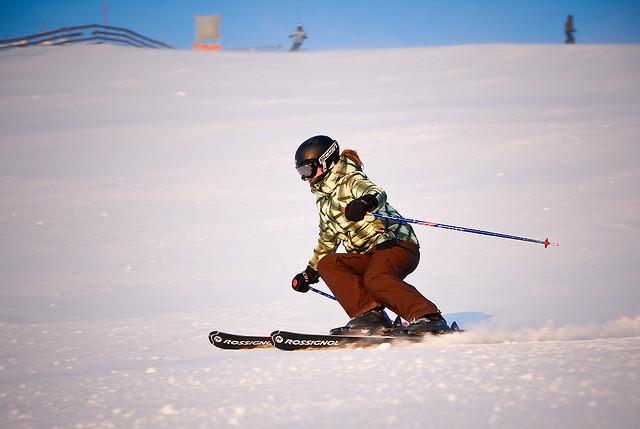What is the person doing?
Give a very brief answer. Skiing. How many people do you see?
Be succinct. 3. Is this person using ski poles?
Quick response, please. Yes. What color is the man's jacket?
Give a very brief answer. Green. What color jacket is this person wearing?
Be succinct. Plaid. Is this a crowded mountain slope?
Keep it brief. No. 